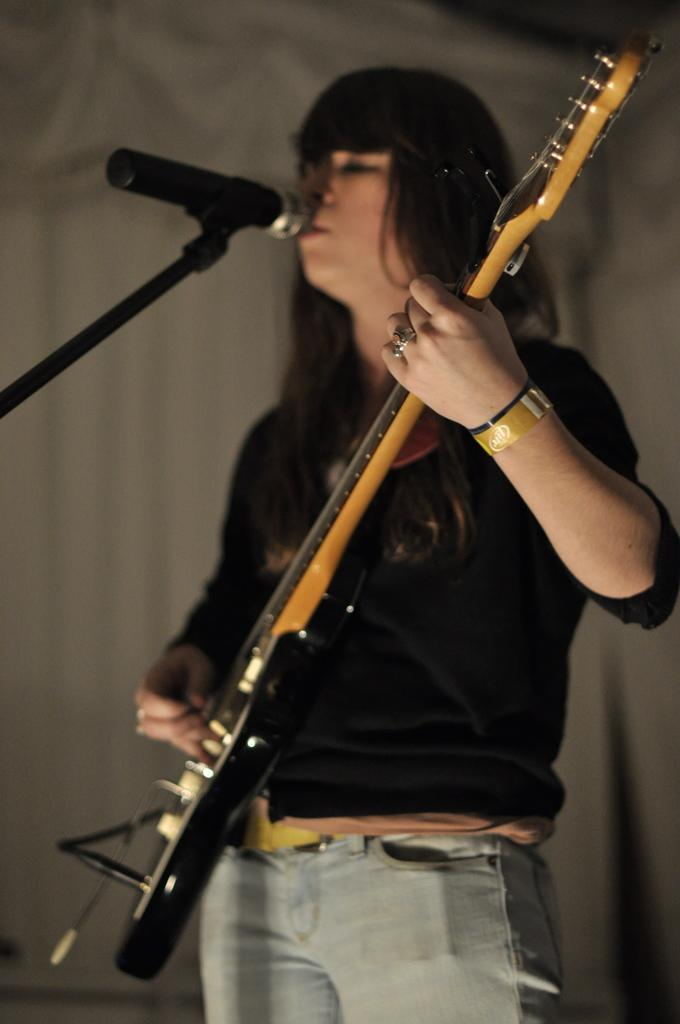What is the person in the image doing? The person is playing a guitar. What object is visible on the left side of the image? There is a microphone on the left side of the image. What song is the person singing while playing the guitar in the image? There is no information about the song being sung in the image, as it only shows a person playing a guitar and a microphone. 